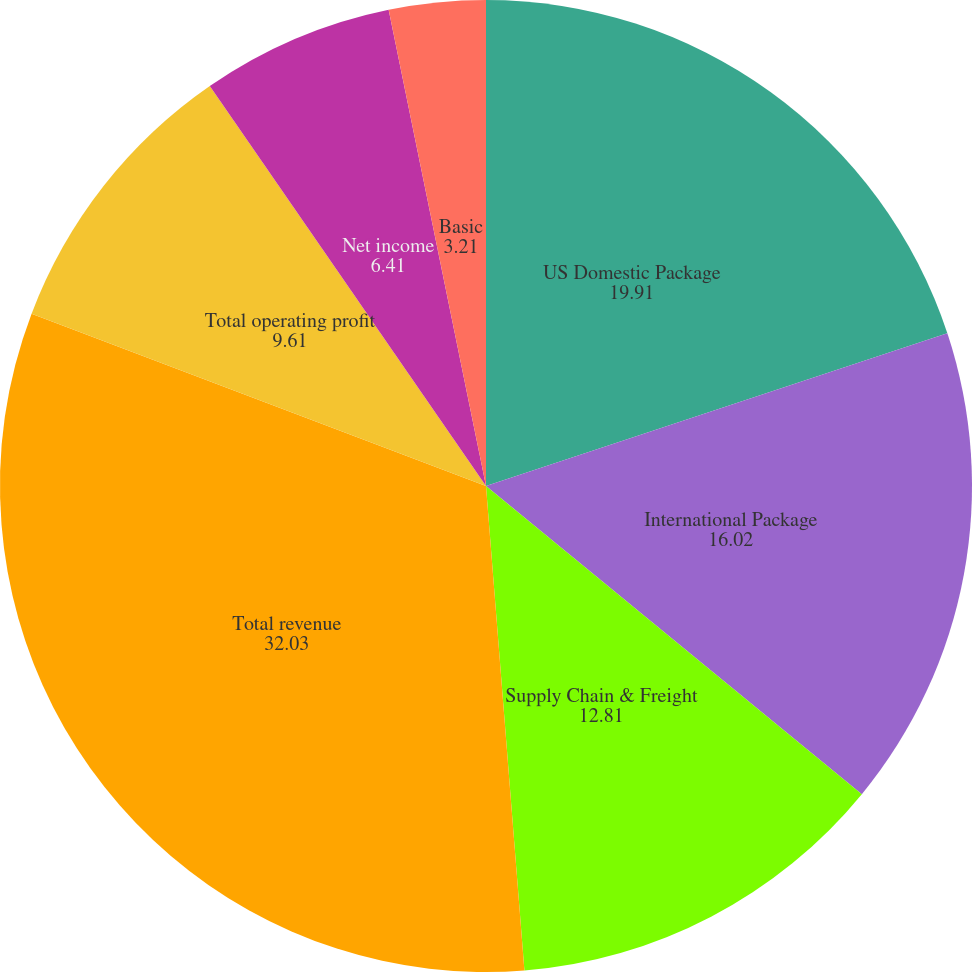<chart> <loc_0><loc_0><loc_500><loc_500><pie_chart><fcel>US Domestic Package<fcel>International Package<fcel>Supply Chain & Freight<fcel>Total revenue<fcel>Total operating profit<fcel>Net income<fcel>Basic<fcel>Diluted<nl><fcel>19.91%<fcel>16.02%<fcel>12.81%<fcel>32.03%<fcel>9.61%<fcel>6.41%<fcel>3.21%<fcel>0.0%<nl></chart> 